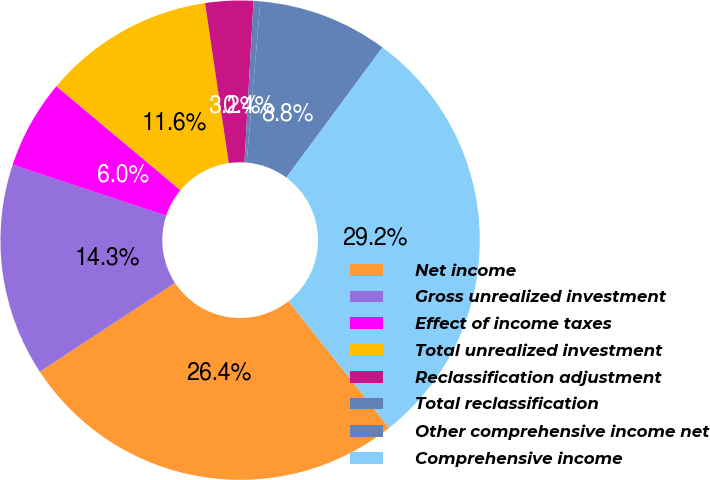Convert chart to OTSL. <chart><loc_0><loc_0><loc_500><loc_500><pie_chart><fcel>Net income<fcel>Gross unrealized investment<fcel>Effect of income taxes<fcel>Total unrealized investment<fcel>Reclassification adjustment<fcel>Total reclassification<fcel>Other comprehensive income net<fcel>Comprehensive income<nl><fcel>26.43%<fcel>14.34%<fcel>6.01%<fcel>11.56%<fcel>3.23%<fcel>0.45%<fcel>8.78%<fcel>29.2%<nl></chart> 